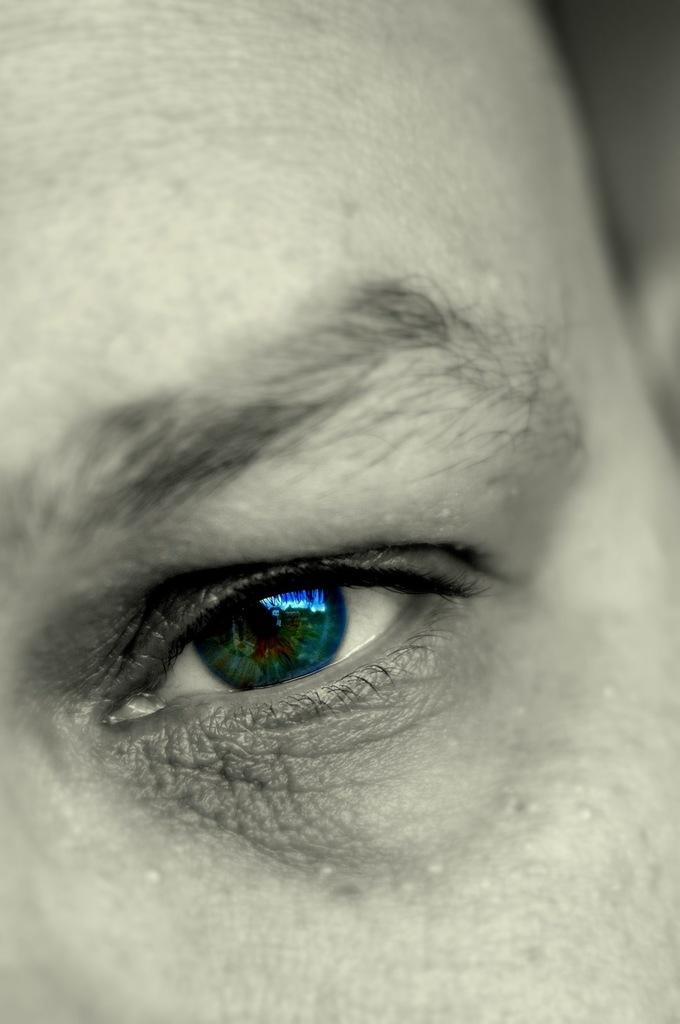What is the main subject of the image? The main subject of the image is a person's eye. Can you describe any specific features of the eye in the image? Unfortunately, the image only shows the eye, so it's difficult to describe any specific features. How many hens are visible in the image? There are no hens present in the image; it only shows a person's eye. 